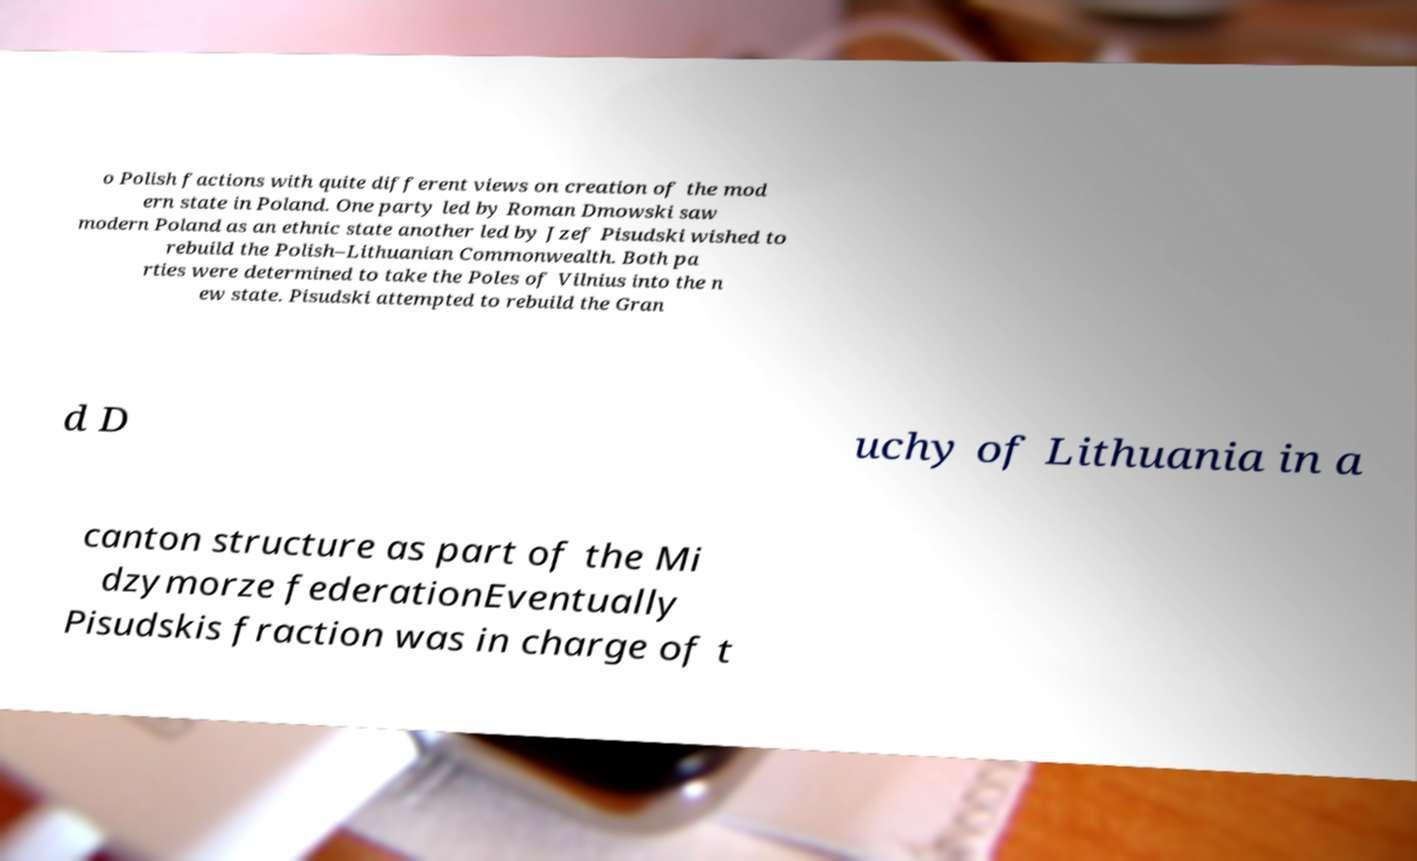Can you read and provide the text displayed in the image?This photo seems to have some interesting text. Can you extract and type it out for me? o Polish factions with quite different views on creation of the mod ern state in Poland. One party led by Roman Dmowski saw modern Poland as an ethnic state another led by Jzef Pisudski wished to rebuild the Polish–Lithuanian Commonwealth. Both pa rties were determined to take the Poles of Vilnius into the n ew state. Pisudski attempted to rebuild the Gran d D uchy of Lithuania in a canton structure as part of the Mi dzymorze federationEventually Pisudskis fraction was in charge of t 